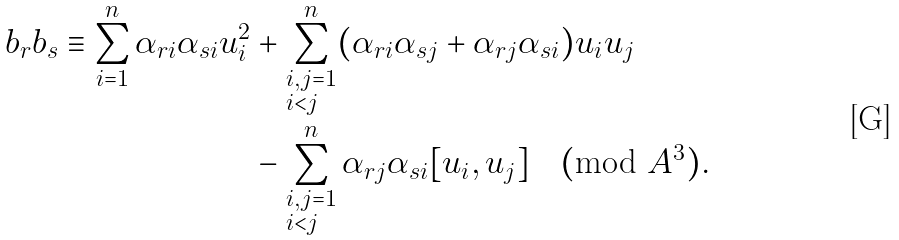Convert formula to latex. <formula><loc_0><loc_0><loc_500><loc_500>b _ { r } b _ { s } \equiv \sum _ { i = 1 } ^ { n } \alpha _ { r i } \alpha _ { s i } u _ { i } ^ { 2 } & + \sum _ { \begin{subarray} { c } i , j = 1 \\ i < j \end{subarray} } ^ { n } ( \alpha _ { r i } \alpha _ { s j } + \alpha _ { r j } \alpha _ { s i } ) u _ { i } u _ { j } \\ & - \sum _ { \begin{subarray} { c } i , j = 1 \\ i < j \end{subarray} } ^ { n } \alpha _ { r j } \alpha _ { s i } [ u _ { i } , u _ { j } ] \pmod { A ^ { 3 } } .</formula> 